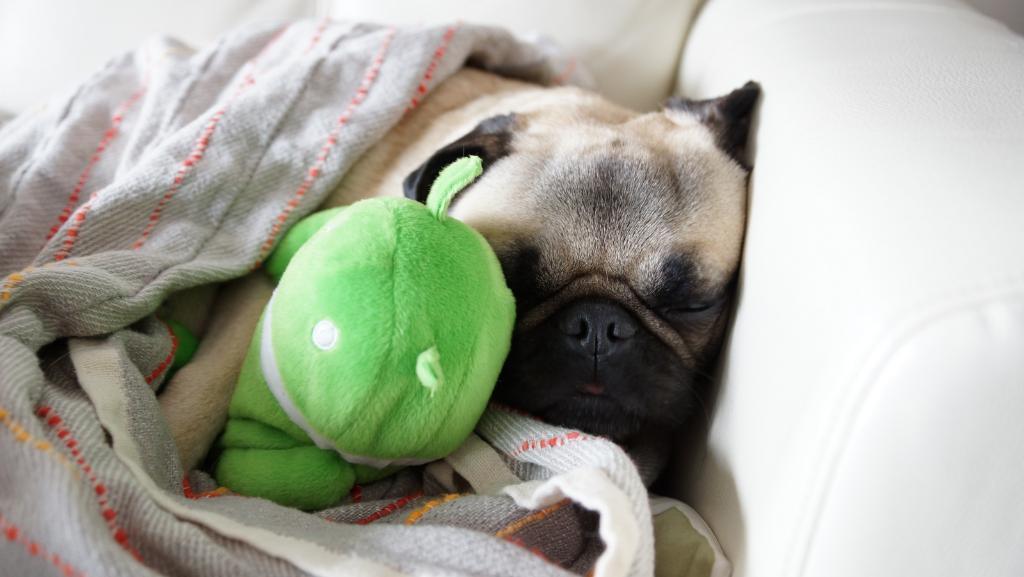Can you describe this image briefly? this is a picture of a dog sleeping on a couch and a blanket covered on it. even we can see a toy 